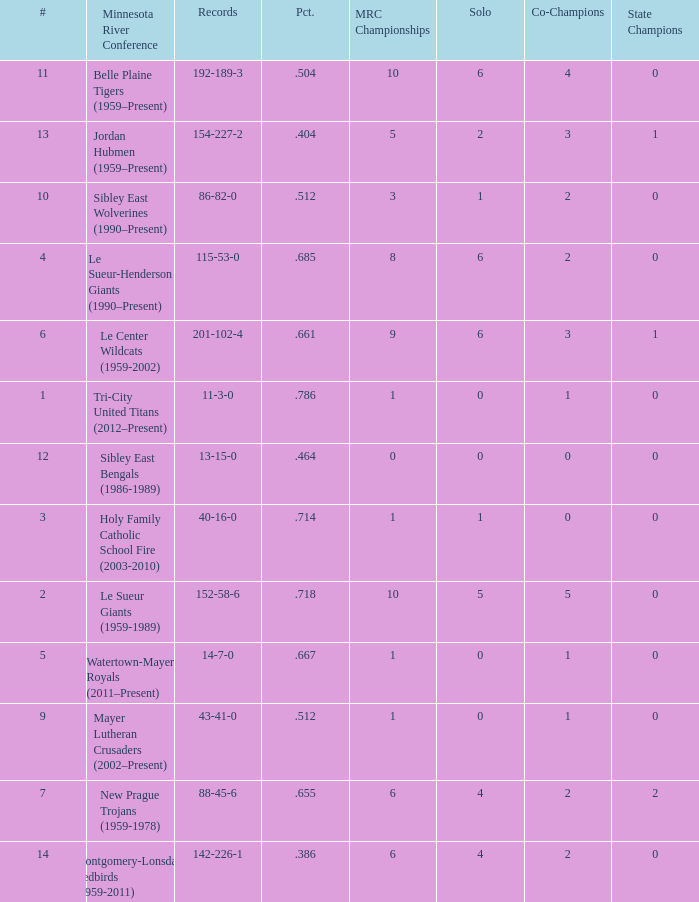What are the record(s) for the team with a winning percentage of .464? 13-15-0. 